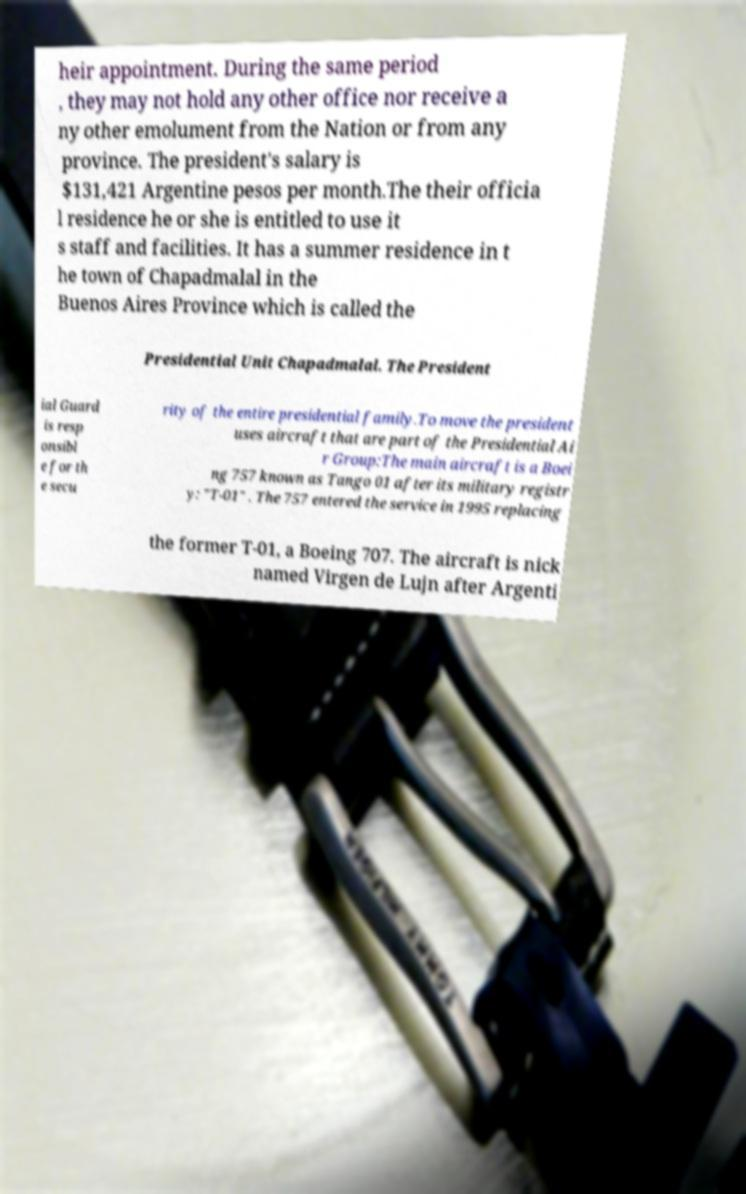For documentation purposes, I need the text within this image transcribed. Could you provide that? heir appointment. During the same period , they may not hold any other office nor receive a ny other emolument from the Nation or from any province. The president's salary is $131,421 Argentine pesos per month.The their officia l residence he or she is entitled to use it s staff and facilities. It has a summer residence in t he town of Chapadmalal in the Buenos Aires Province which is called the Presidential Unit Chapadmalal. The President ial Guard is resp onsibl e for th e secu rity of the entire presidential family.To move the president uses aircraft that are part of the Presidential Ai r Group:The main aircraft is a Boei ng 757 known as Tango 01 after its military registr y: "T-01" . The 757 entered the service in 1995 replacing the former T-01, a Boeing 707. The aircraft is nick named Virgen de Lujn after Argenti 